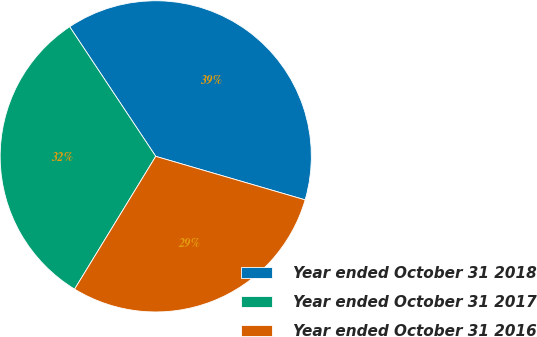Convert chart to OTSL. <chart><loc_0><loc_0><loc_500><loc_500><pie_chart><fcel>Year ended October 31 2018<fcel>Year ended October 31 2017<fcel>Year ended October 31 2016<nl><fcel>38.84%<fcel>31.94%<fcel>29.22%<nl></chart> 